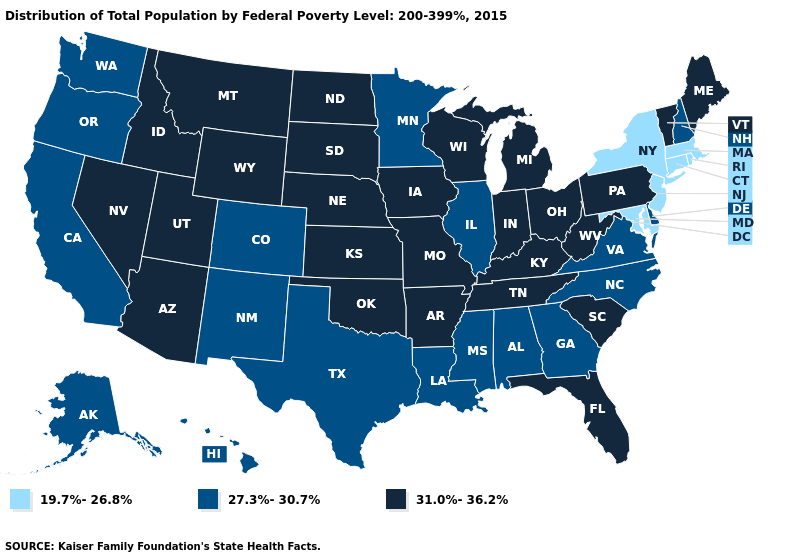Among the states that border Wyoming , which have the highest value?
Keep it brief. Idaho, Montana, Nebraska, South Dakota, Utah. What is the highest value in the Northeast ?
Quick response, please. 31.0%-36.2%. What is the value of Massachusetts?
Be succinct. 19.7%-26.8%. Does North Dakota have the same value as Mississippi?
Concise answer only. No. Among the states that border Louisiana , does Mississippi have the lowest value?
Quick response, please. Yes. Among the states that border Wisconsin , does Michigan have the highest value?
Answer briefly. Yes. Does Vermont have the highest value in the USA?
Concise answer only. Yes. What is the lowest value in the Northeast?
Answer briefly. 19.7%-26.8%. Name the states that have a value in the range 31.0%-36.2%?
Write a very short answer. Arizona, Arkansas, Florida, Idaho, Indiana, Iowa, Kansas, Kentucky, Maine, Michigan, Missouri, Montana, Nebraska, Nevada, North Dakota, Ohio, Oklahoma, Pennsylvania, South Carolina, South Dakota, Tennessee, Utah, Vermont, West Virginia, Wisconsin, Wyoming. Among the states that border Michigan , which have the lowest value?
Concise answer only. Indiana, Ohio, Wisconsin. What is the value of Oregon?
Be succinct. 27.3%-30.7%. Among the states that border Wisconsin , does Illinois have the lowest value?
Give a very brief answer. Yes. Does Arkansas have the highest value in the South?
Quick response, please. Yes. Name the states that have a value in the range 19.7%-26.8%?
Write a very short answer. Connecticut, Maryland, Massachusetts, New Jersey, New York, Rhode Island. What is the value of Hawaii?
Give a very brief answer. 27.3%-30.7%. 